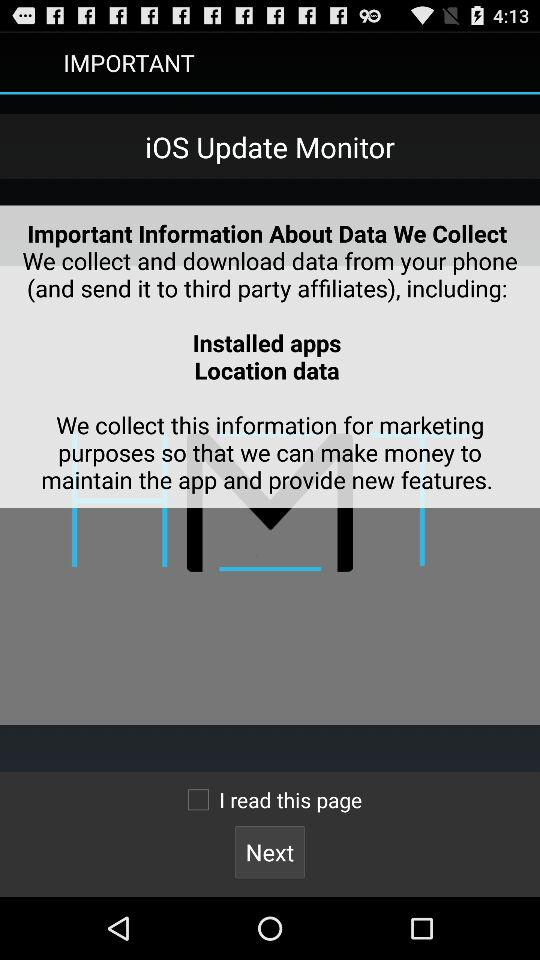What is the status of "I read this page"? The status is "off". 